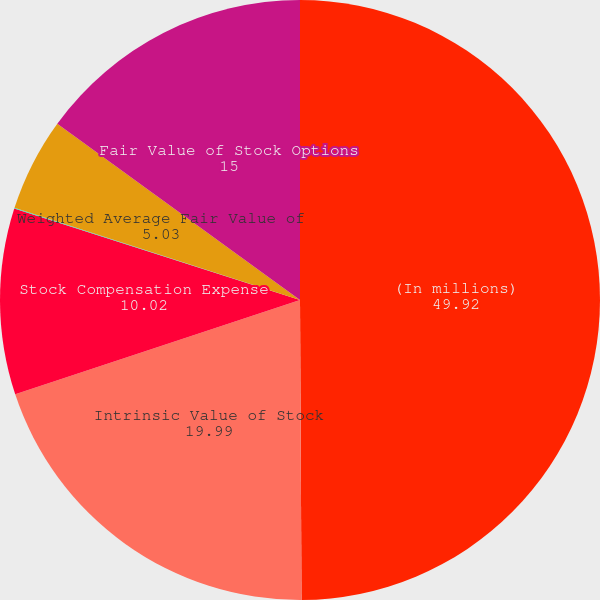<chart> <loc_0><loc_0><loc_500><loc_500><pie_chart><fcel>(In millions)<fcel>Intrinsic Value of Stock<fcel>Stock Compensation Expense<fcel>Issued Stock Options<fcel>Weighted Average Fair Value of<fcel>Fair Value of Stock Options<nl><fcel>49.92%<fcel>19.99%<fcel>10.02%<fcel>0.04%<fcel>5.03%<fcel>15.0%<nl></chart> 